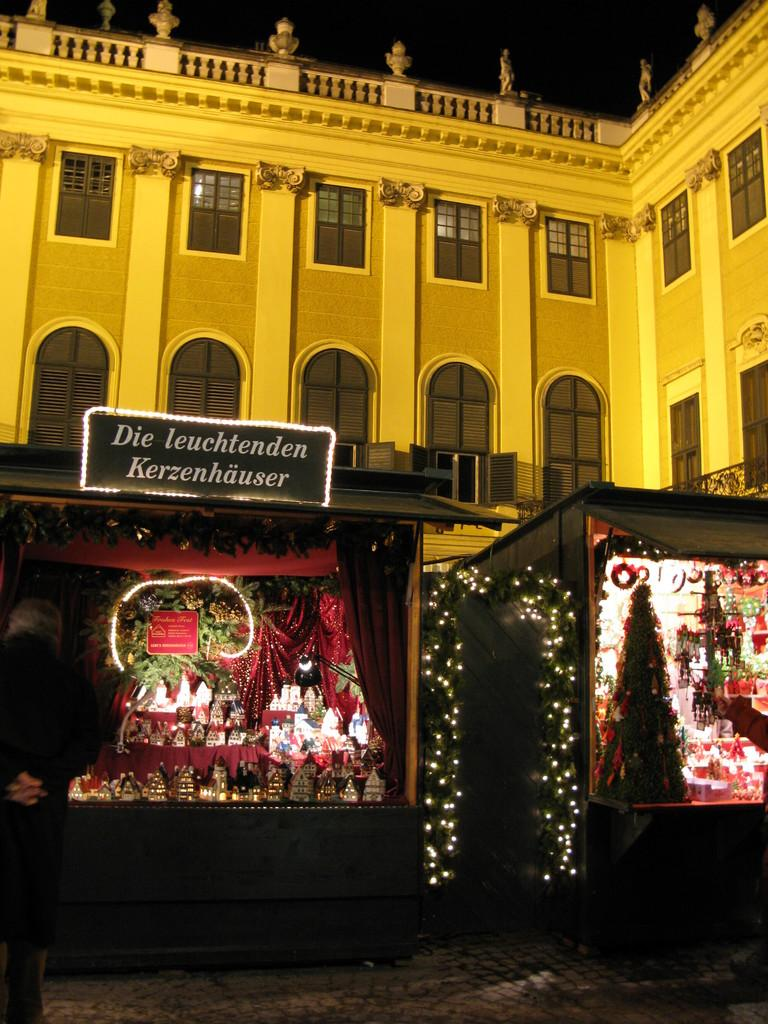What is located in the foreground of the picture? There are Christmas trees, toys, a board, and a light in the foreground of the picture. What other objects can be seen in the foreground of the picture? There are other objects in the foreground of the picture. What is visible in the background of the picture? There is a building in the background of the picture. What is at the bottom of the picture? There is a pavement at the bottom of the picture. What type of cheese can be seen melting on the board in the image? There is no cheese present in the image; the board is not associated with any food items. What curve can be seen in the image? There is no curve visible in the image; the objects and structures are mostly straight or angular. 